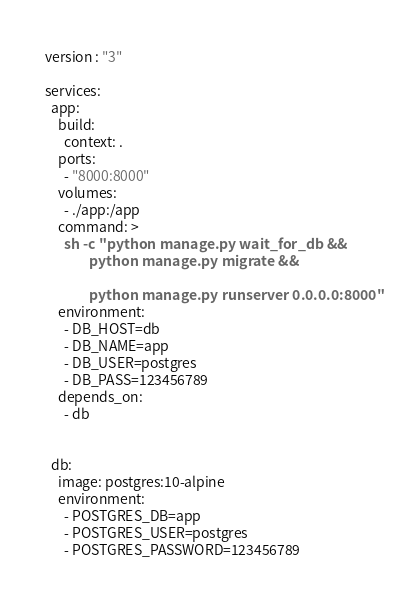<code> <loc_0><loc_0><loc_500><loc_500><_YAML_>version : "3"

services:
  app:
    build:
      context: .
    ports:
      - "8000:8000"
    volumes:
      - ./app:/app
    command: >
      sh -c "python manage.py wait_for_db &&
              python manage.py migrate &&  

              python manage.py runserver 0.0.0.0:8000"
    environment:
      - DB_HOST=db
      - DB_NAME=app
      - DB_USER=postgres
      - DB_PASS=123456789
    depends_on:
      - db


  db:
    image: postgres:10-alpine
    environment:
      - POSTGRES_DB=app
      - POSTGRES_USER=postgres
      - POSTGRES_PASSWORD=123456789
</code> 